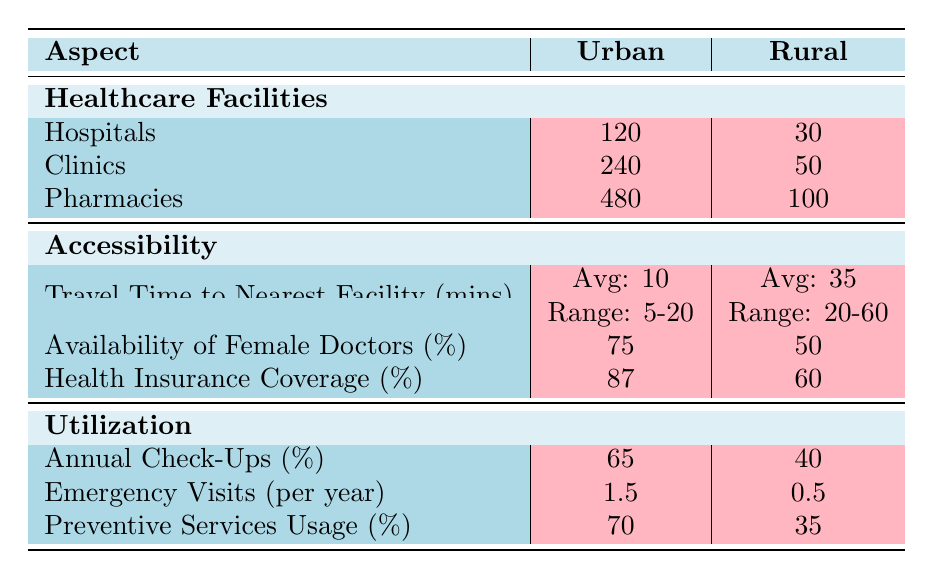What is the total number of hospitals in urban areas? The table shows that there are 120 hospitals in urban areas.
Answer: 120 What percentage of women have access to health insurance in rural areas? According to the table, 60% of women in rural areas have health insurance coverage.
Answer: 60% How many more clinics are there in urban areas compared to rural areas? In urban areas, there are 240 clinics, while in rural areas, there are 50 clinics. The difference is 240 - 50 = 190.
Answer: 190 What is the average travel time to the nearest healthcare facility in urban areas? The average travel time to the nearest facility in urban areas is stated as 10 minutes.
Answer: 10 minutes Is the availability of female doctors higher in rural or urban areas? The table lists 75% availability of female doctors in urban areas and 50% in rural areas, thus urban areas have higher availability.
Answer: Yes, it is higher in urban areas How much lower is the percentage of annual check-ups utilization in rural areas compared to urban areas? Urban areas have 65% annual check-ups while rural areas have 40%. The difference is 65 - 40 = 25%.
Answer: 25% Calculate the total number of healthcare facilities (hospitals, clinics, and pharmacies) in rural areas. In rural areas: 30 hospitals + 50 clinics + 100 pharmacies = 180 total facilities.
Answer: 180 What can be inferred about the emergency visits per year from urban to rural areas? In urban areas, there are 1.5 emergency visits per year, and in rural areas, there are only 0.5. This indicates a lower reliance on emergency services in rural areas.
Answer: Fewer emergency visits in rural areas Do rural areas have more or fewer preventive services usage compared to urban areas? The table shows 35% usage in rural areas versus 70% in urban areas, meaning rural areas have fewer preventive services usage.
Answer: Fewer in rural areas What is the range of travel time to the nearest healthcare facility in rural areas? The travel time range to the nearest facility in rural areas is specified as 20-60 minutes.
Answer: 20-60 minutes 